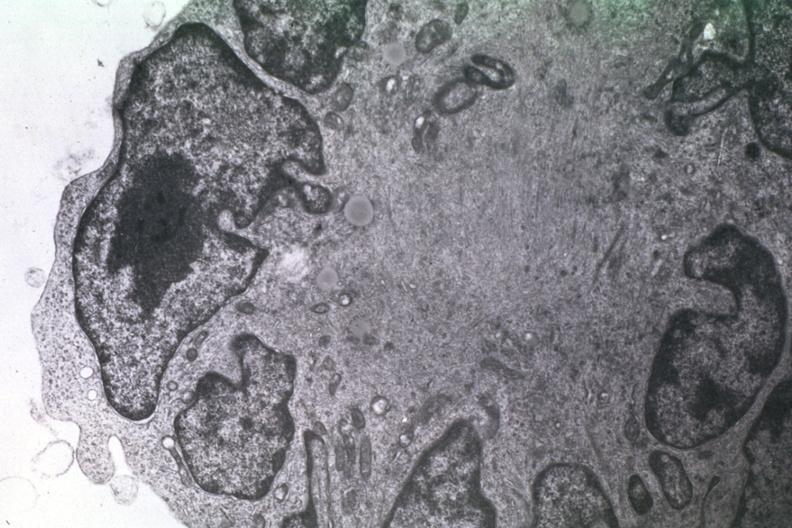s typical ivory vertebra present?
Answer the question using a single word or phrase. No 